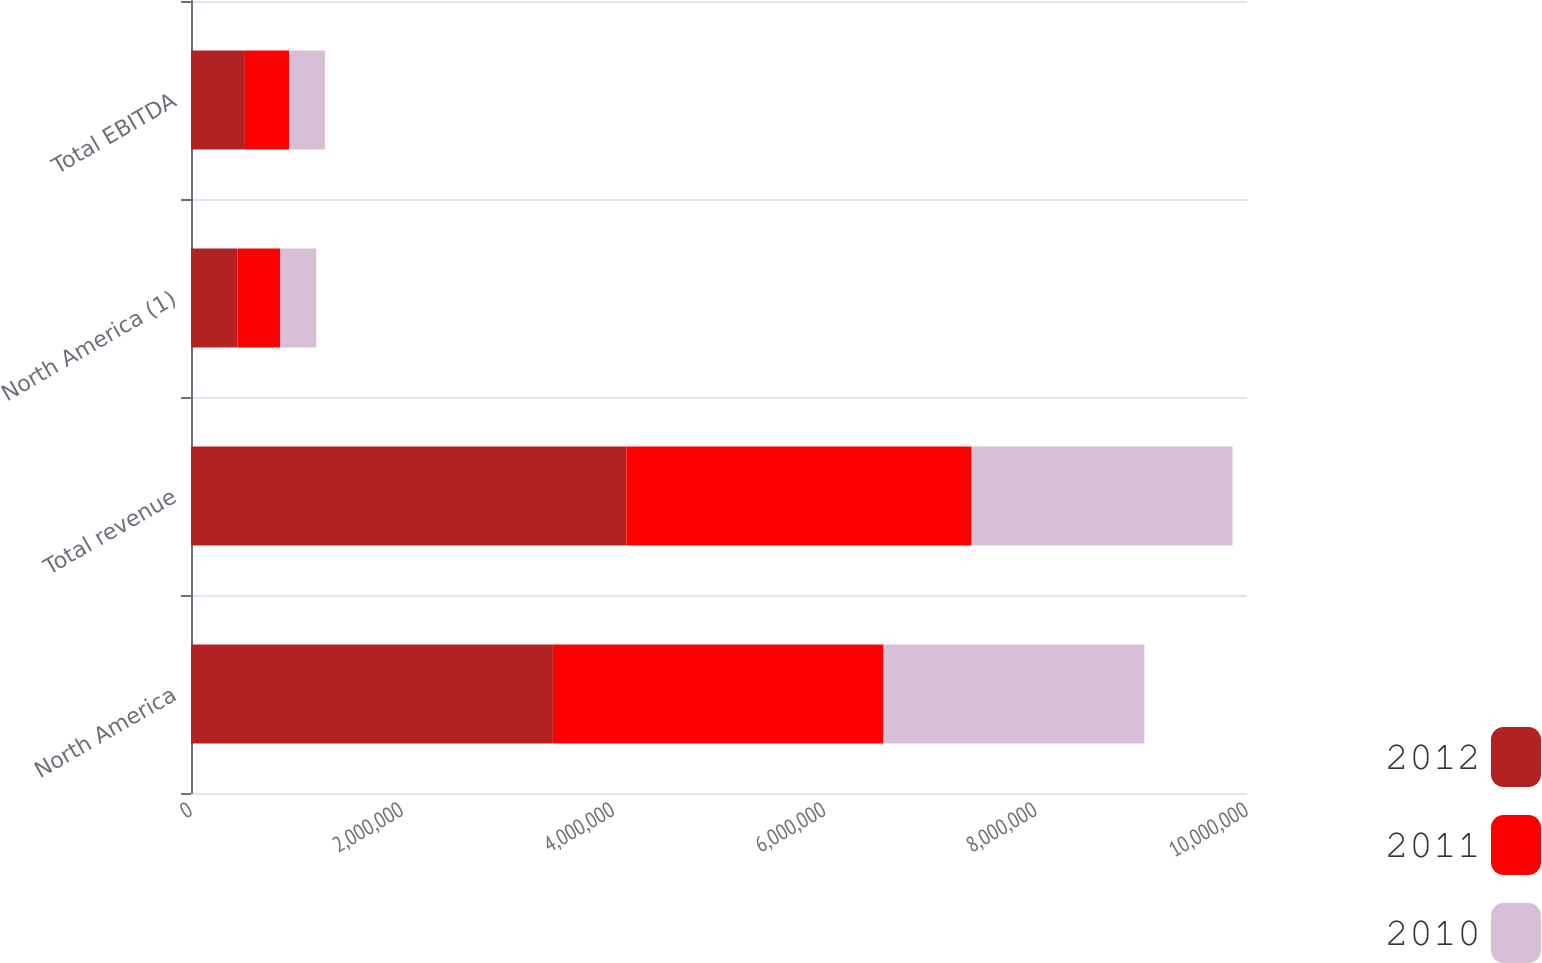Convert chart to OTSL. <chart><loc_0><loc_0><loc_500><loc_500><stacked_bar_chart><ecel><fcel>North America<fcel>Total revenue<fcel>North America (1)<fcel>Total EBITDA<nl><fcel>2012<fcel>3.42686e+06<fcel>4.12293e+06<fcel>440448<fcel>510547<nl><fcel>2011<fcel>3.13138e+06<fcel>3.26986e+06<fcel>405924<fcel>418068<nl><fcel>2010<fcel>2.46988e+06<fcel>2.46988e+06<fcel>339869<fcel>339869<nl></chart> 